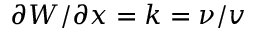Convert formula to latex. <formula><loc_0><loc_0><loc_500><loc_500>\partial W / \partial x = k = \nu / v</formula> 